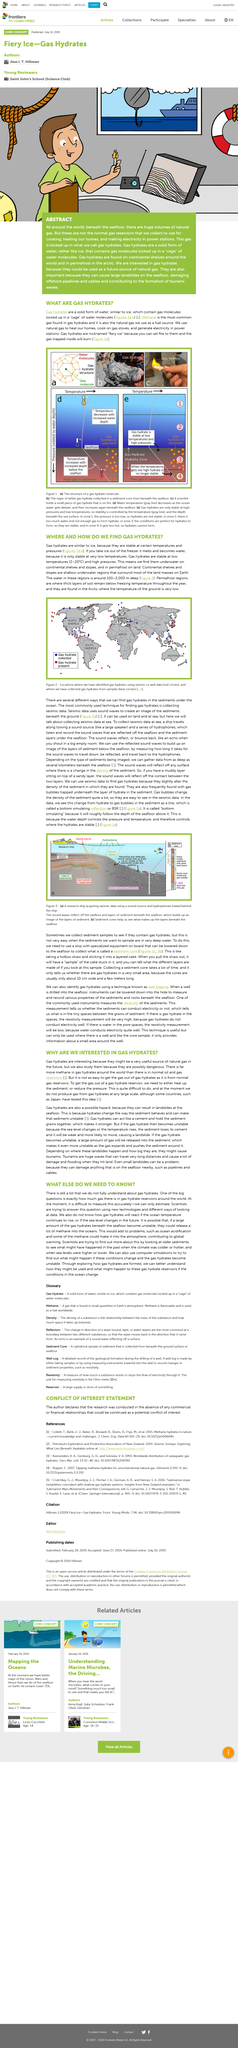Draw attention to some important aspects in this diagram. Gas hydrates exist in a solid form. Gas hydrates are of significant interest due to their potential as a future source of natural gas, which could be harnessed for energy generation. Permafrost regions are distinguished by the thick layers of soil that remain frozen due to their low temperatures that persist throughout the year. Gas hydrates are a type of ice that contain gas molecules trapped within the ice crystal structure. Methane is the most common gas found in gas hydrates. Gas hydrates, commonly known as 'fiery ice,' are a nickname for a type of ice-like substance that contains a mixture of water, gas, and solid particles. 